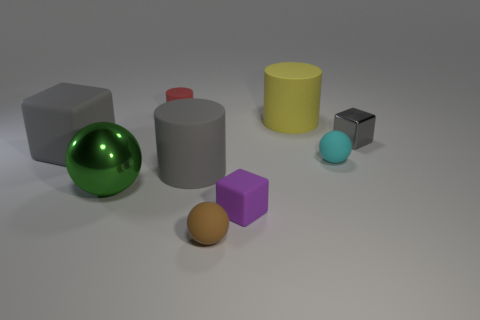What number of other things are there of the same size as the yellow thing?
Your answer should be compact. 3. The green metal thing is what size?
Offer a very short reply. Large. Are the small gray object that is to the right of the yellow rubber object and the big green object made of the same material?
Provide a short and direct response. Yes. What is the color of the other tiny rubber thing that is the same shape as the yellow matte thing?
Your response must be concise. Red. There is a shiny thing that is to the left of the red rubber cylinder; does it have the same color as the tiny rubber cylinder?
Keep it short and to the point. No. There is a small gray thing; are there any large green spheres right of it?
Provide a short and direct response. No. There is a block that is behind the gray matte cylinder and left of the gray shiny cube; what color is it?
Provide a short and direct response. Gray. The matte object that is the same color as the big rubber cube is what shape?
Provide a short and direct response. Cylinder. What is the size of the metallic object that is left of the tiny cube that is right of the tiny purple rubber thing?
Your response must be concise. Large. How many cylinders are either gray shiny things or big green objects?
Your answer should be compact. 0. 